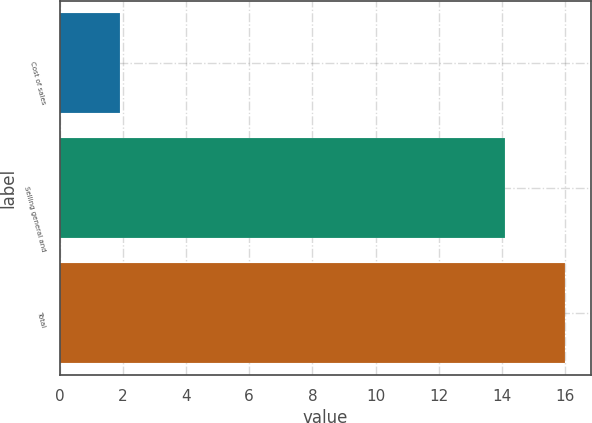Convert chart. <chart><loc_0><loc_0><loc_500><loc_500><bar_chart><fcel>Cost of sales<fcel>Selling general and<fcel>Total<nl><fcel>1.9<fcel>14.1<fcel>16<nl></chart> 